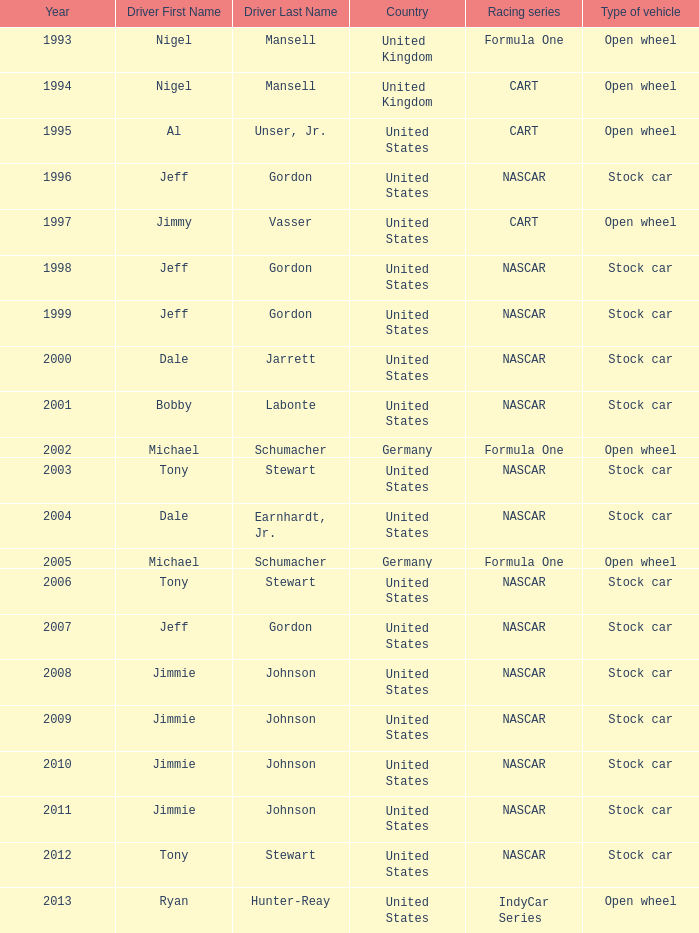What Nation of citizenship has a stock car vehicle with a year of 1999? United States. 